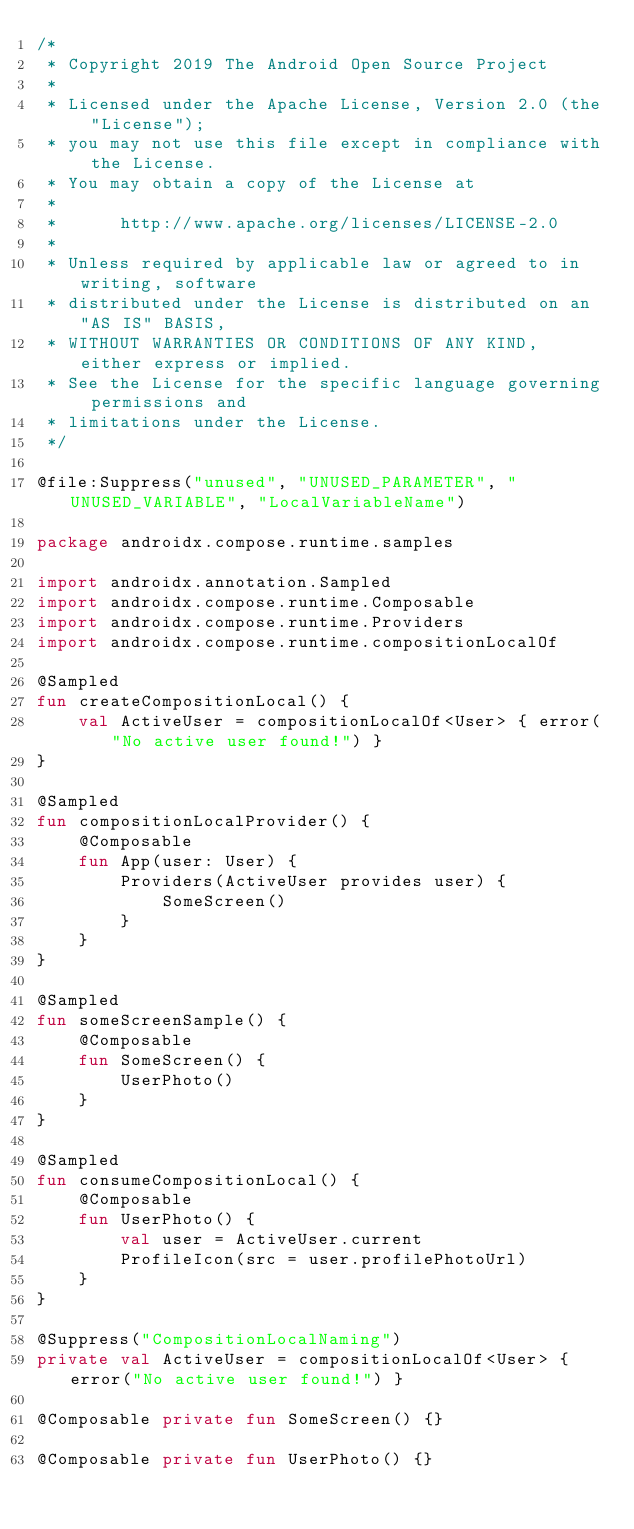<code> <loc_0><loc_0><loc_500><loc_500><_Kotlin_>/*
 * Copyright 2019 The Android Open Source Project
 *
 * Licensed under the Apache License, Version 2.0 (the "License");
 * you may not use this file except in compliance with the License.
 * You may obtain a copy of the License at
 *
 *      http://www.apache.org/licenses/LICENSE-2.0
 *
 * Unless required by applicable law or agreed to in writing, software
 * distributed under the License is distributed on an "AS IS" BASIS,
 * WITHOUT WARRANTIES OR CONDITIONS OF ANY KIND, either express or implied.
 * See the License for the specific language governing permissions and
 * limitations under the License.
 */

@file:Suppress("unused", "UNUSED_PARAMETER", "UNUSED_VARIABLE", "LocalVariableName")

package androidx.compose.runtime.samples

import androidx.annotation.Sampled
import androidx.compose.runtime.Composable
import androidx.compose.runtime.Providers
import androidx.compose.runtime.compositionLocalOf

@Sampled
fun createCompositionLocal() {
    val ActiveUser = compositionLocalOf<User> { error("No active user found!") }
}

@Sampled
fun compositionLocalProvider() {
    @Composable
    fun App(user: User) {
        Providers(ActiveUser provides user) {
            SomeScreen()
        }
    }
}

@Sampled
fun someScreenSample() {
    @Composable
    fun SomeScreen() {
        UserPhoto()
    }
}

@Sampled
fun consumeCompositionLocal() {
    @Composable
    fun UserPhoto() {
        val user = ActiveUser.current
        ProfileIcon(src = user.profilePhotoUrl)
    }
}

@Suppress("CompositionLocalNaming")
private val ActiveUser = compositionLocalOf<User> { error("No active user found!") }

@Composable private fun SomeScreen() {}

@Composable private fun UserPhoto() {}
</code> 